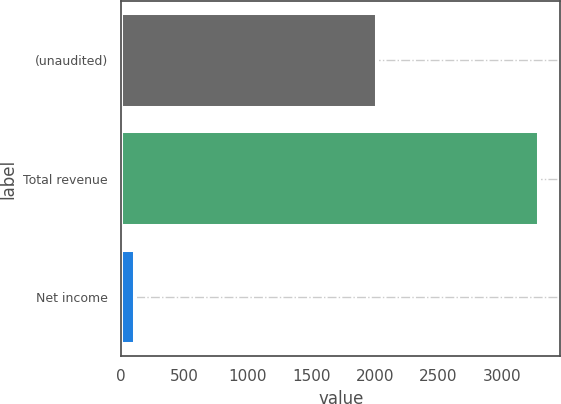Convert chart to OTSL. <chart><loc_0><loc_0><loc_500><loc_500><bar_chart><fcel>(unaudited)<fcel>Total revenue<fcel>Net income<nl><fcel>2015<fcel>3297.7<fcel>107.6<nl></chart> 